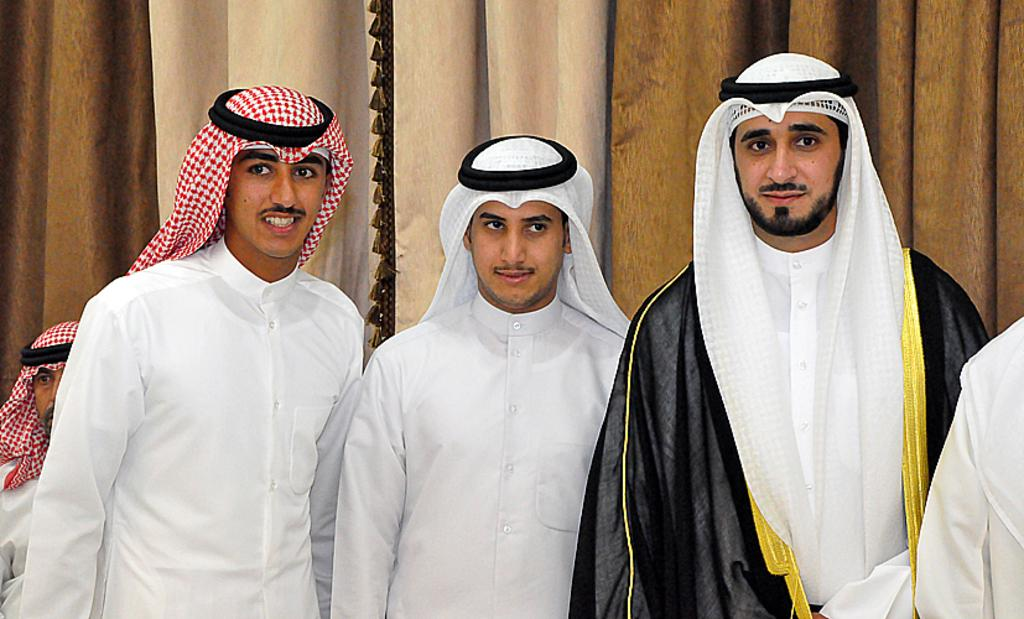How many people are present in the image? There are a few people in the image. What can be seen in the background of the image? There are curtains visible in the background of the image. What type of work are the sisters doing in the image? There is no mention of sisters or work in the image, so we cannot answer this question. 